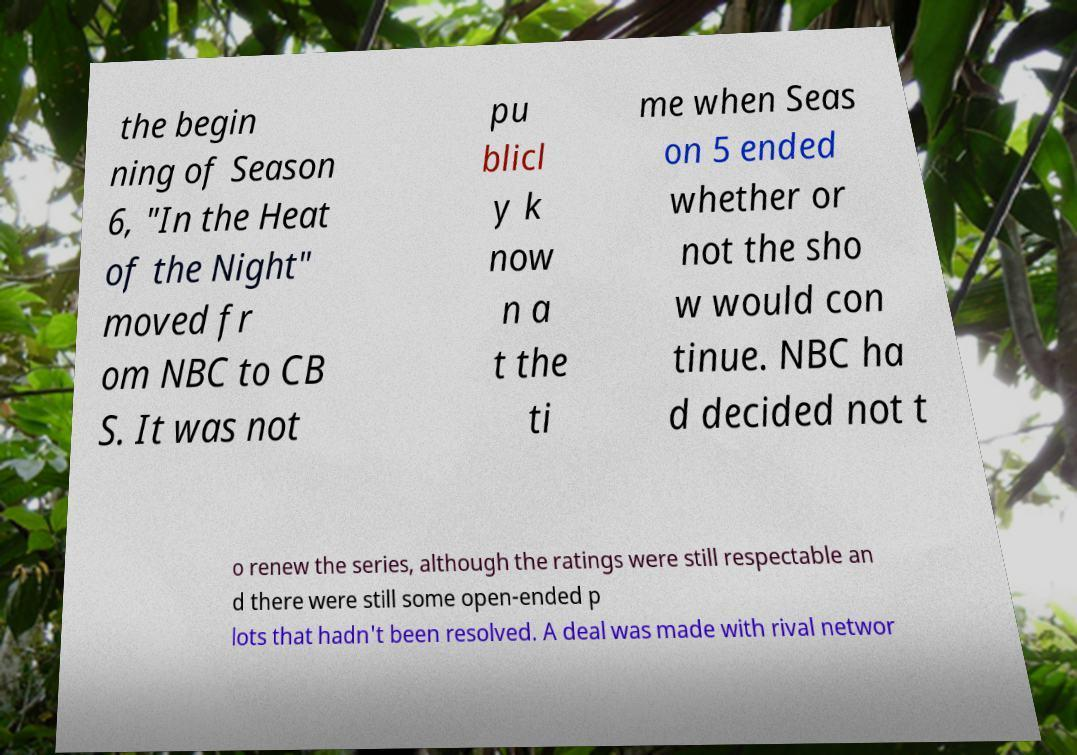For documentation purposes, I need the text within this image transcribed. Could you provide that? the begin ning of Season 6, "In the Heat of the Night" moved fr om NBC to CB S. It was not pu blicl y k now n a t the ti me when Seas on 5 ended whether or not the sho w would con tinue. NBC ha d decided not t o renew the series, although the ratings were still respectable an d there were still some open-ended p lots that hadn't been resolved. A deal was made with rival networ 